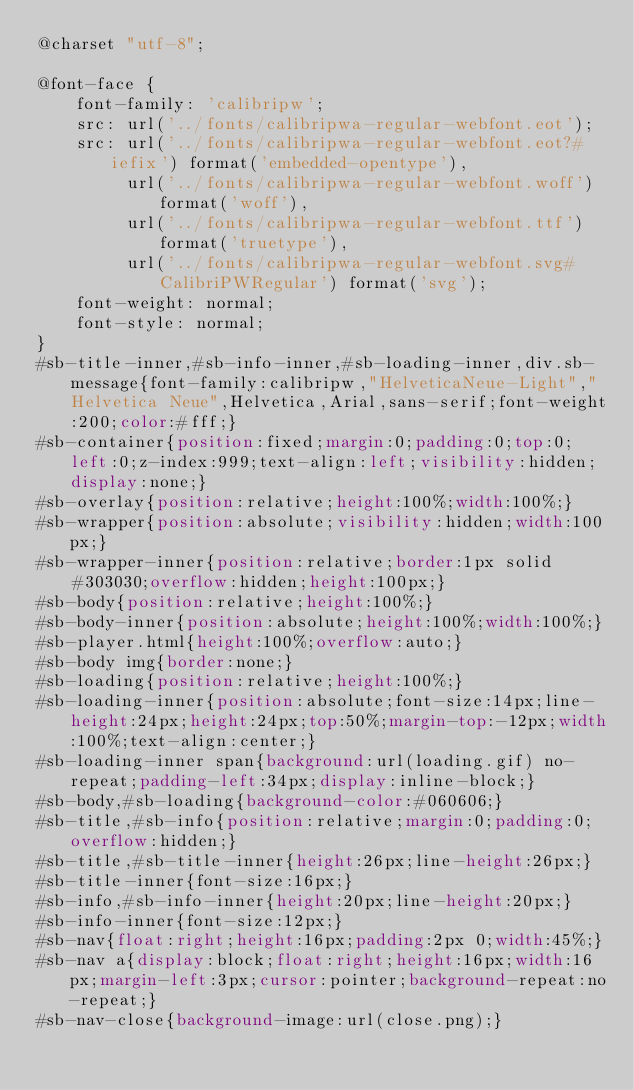<code> <loc_0><loc_0><loc_500><loc_500><_CSS_>@charset "utf-8";

@font-face {
    font-family: 'calibripw';
    src: url('../fonts/calibripwa-regular-webfont.eot');
    src: url('../fonts/calibripwa-regular-webfont.eot?#iefix') format('embedded-opentype'),
         url('../fonts/calibripwa-regular-webfont.woff') format('woff'),
         url('../fonts/calibripwa-regular-webfont.ttf') format('truetype'),
         url('../fonts/calibripwa-regular-webfont.svg#CalibriPWRegular') format('svg');
    font-weight: normal;
    font-style: normal;
}
#sb-title-inner,#sb-info-inner,#sb-loading-inner,div.sb-message{font-family:calibripw,"HelveticaNeue-Light","Helvetica Neue",Helvetica,Arial,sans-serif;font-weight:200;color:#fff;}
#sb-container{position:fixed;margin:0;padding:0;top:0;left:0;z-index:999;text-align:left;visibility:hidden;display:none;}
#sb-overlay{position:relative;height:100%;width:100%;}
#sb-wrapper{position:absolute;visibility:hidden;width:100px;}
#sb-wrapper-inner{position:relative;border:1px solid #303030;overflow:hidden;height:100px;}
#sb-body{position:relative;height:100%;}
#sb-body-inner{position:absolute;height:100%;width:100%;}
#sb-player.html{height:100%;overflow:auto;}
#sb-body img{border:none;}
#sb-loading{position:relative;height:100%;}
#sb-loading-inner{position:absolute;font-size:14px;line-height:24px;height:24px;top:50%;margin-top:-12px;width:100%;text-align:center;}
#sb-loading-inner span{background:url(loading.gif) no-repeat;padding-left:34px;display:inline-block;}
#sb-body,#sb-loading{background-color:#060606;}
#sb-title,#sb-info{position:relative;margin:0;padding:0;overflow:hidden;}
#sb-title,#sb-title-inner{height:26px;line-height:26px;}
#sb-title-inner{font-size:16px;}
#sb-info,#sb-info-inner{height:20px;line-height:20px;}
#sb-info-inner{font-size:12px;}
#sb-nav{float:right;height:16px;padding:2px 0;width:45%;}
#sb-nav a{display:block;float:right;height:16px;width:16px;margin-left:3px;cursor:pointer;background-repeat:no-repeat;}
#sb-nav-close{background-image:url(close.png);}</code> 